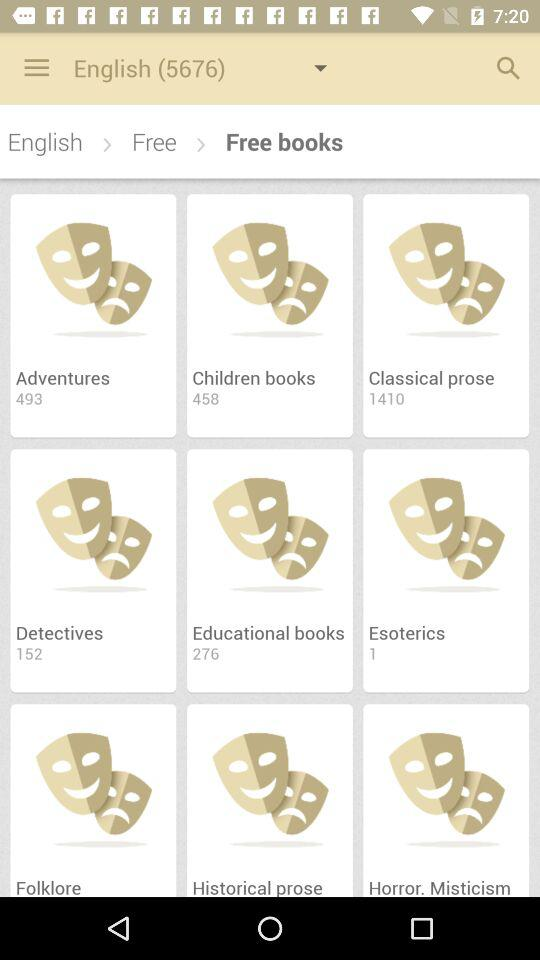What is the application name? The application name is "My Prestigio". 